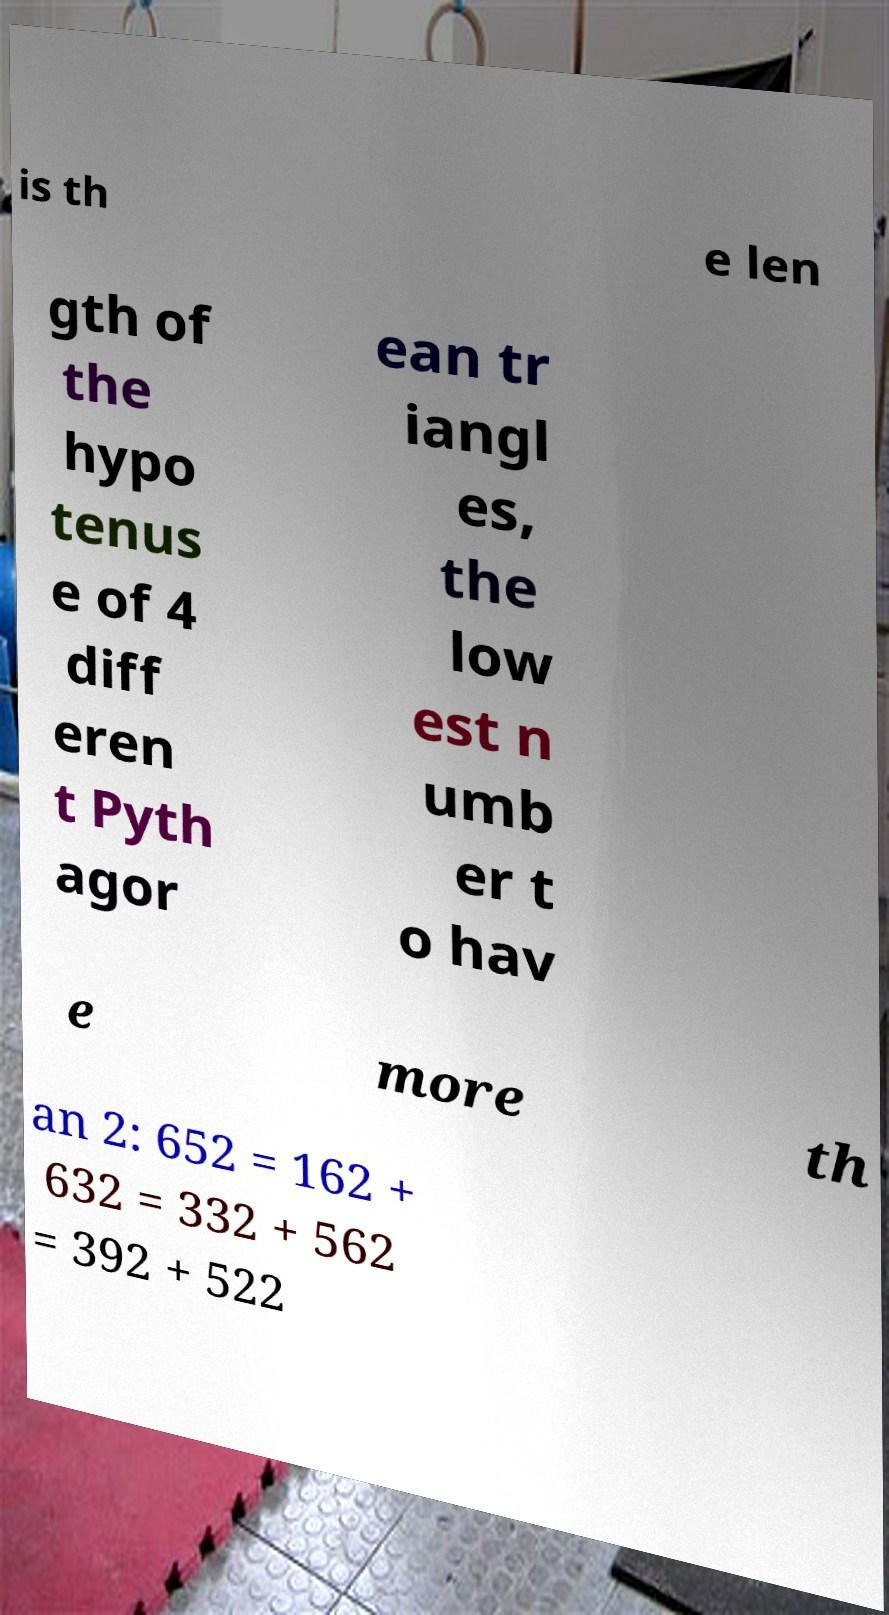Please read and relay the text visible in this image. What does it say? is th e len gth of the hypo tenus e of 4 diff eren t Pyth agor ean tr iangl es, the low est n umb er t o hav e more th an 2: 652 = 162 + 632 = 332 + 562 = 392 + 522 